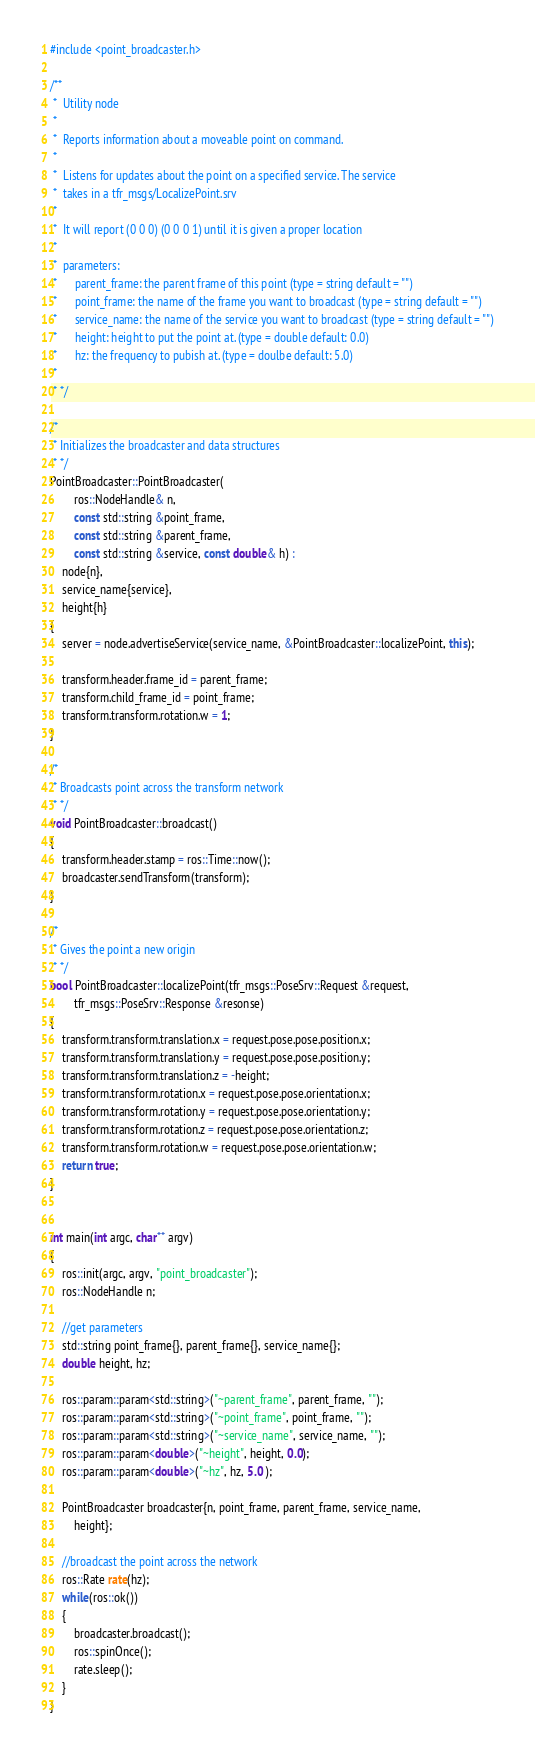Convert code to text. <code><loc_0><loc_0><loc_500><loc_500><_C++_>#include <point_broadcaster.h>

/**
 *  Utility node
 *
 *  Reports information about a moveable point on command.
 *
 *  Listens for updates about the point on a specified service. The service
 *  takes in a tfr_msgs/LocalizePoint.srv
 *
 *  It will report (0 0 0) (0 0 0 1) until it is given a proper location
 *
 *  parameters:
 *      parent_frame: the parent frame of this point (type = string default = "")
 *      point_frame: the name of the frame you want to broadcast (type = string default = "")
 *      service_name: the name of the service you want to broadcast (type = string default = "")
 *      height: height to put the point at. (type = double default: 0.0)
 *      hz: the frequency to pubish at. (type = doulbe default: 5.0)
 *
 * */

/*
 * Initializes the broadcaster and data structures
 * */
PointBroadcaster::PointBroadcaster(
        ros::NodeHandle& n, 
        const std::string &point_frame, 
        const std::string &parent_frame, 
        const std::string &service, const double& h) : 
    node{n}, 
    service_name{service}, 
    height{h}
{
    server = node.advertiseService(service_name, &PointBroadcaster::localizePoint, this);

    transform.header.frame_id = parent_frame;
    transform.child_frame_id = point_frame;
    transform.transform.rotation.w = 1;
}

/*
 * Broadcasts point across the transform network
 * */
void PointBroadcaster::broadcast()
{
    transform.header.stamp = ros::Time::now();
    broadcaster.sendTransform(transform);
}

/*
 * Gives the point a new origin
 * */
bool PointBroadcaster::localizePoint(tfr_msgs::PoseSrv::Request &request,
        tfr_msgs::PoseSrv::Response &resonse)
{
    transform.transform.translation.x = request.pose.pose.position.x;
    transform.transform.translation.y = request.pose.pose.position.y;
    transform.transform.translation.z = -height;
    transform.transform.rotation.x = request.pose.pose.orientation.x;
    transform.transform.rotation.y = request.pose.pose.orientation.y;
    transform.transform.rotation.z = request.pose.pose.orientation.z;
    transform.transform.rotation.w = request.pose.pose.orientation.w;
    return true;
}


int main(int argc, char** argv)
{
    ros::init(argc, argv, "point_broadcaster");
    ros::NodeHandle n;

    //get parameters
    std::string point_frame{}, parent_frame{}, service_name{};
    double height, hz;

    ros::param::param<std::string>("~parent_frame", parent_frame, "");
    ros::param::param<std::string>("~point_frame", point_frame, "");
    ros::param::param<std::string>("~service_name", service_name, "");
    ros::param::param<double>("~height", height, 0.0);
    ros::param::param<double>("~hz", hz, 5.0 );

    PointBroadcaster broadcaster{n, point_frame, parent_frame, service_name,
        height};

    //broadcast the point across the network
    ros::Rate rate(hz);
    while(ros::ok())
    {
        broadcaster.broadcast();
        ros::spinOnce();
        rate.sleep();
    }
}
</code> 